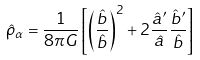Convert formula to latex. <formula><loc_0><loc_0><loc_500><loc_500>\hat { \rho } _ { \alpha } = \frac { 1 } { 8 \pi G } \left [ \left ( \frac { \hat { b } } { \hat { b } } \right ) ^ { 2 } + 2 \frac { \hat { a } ^ { \prime } } { \hat { a } } \frac { \hat { b } ^ { \prime } } { \hat { b } } \right ]</formula> 